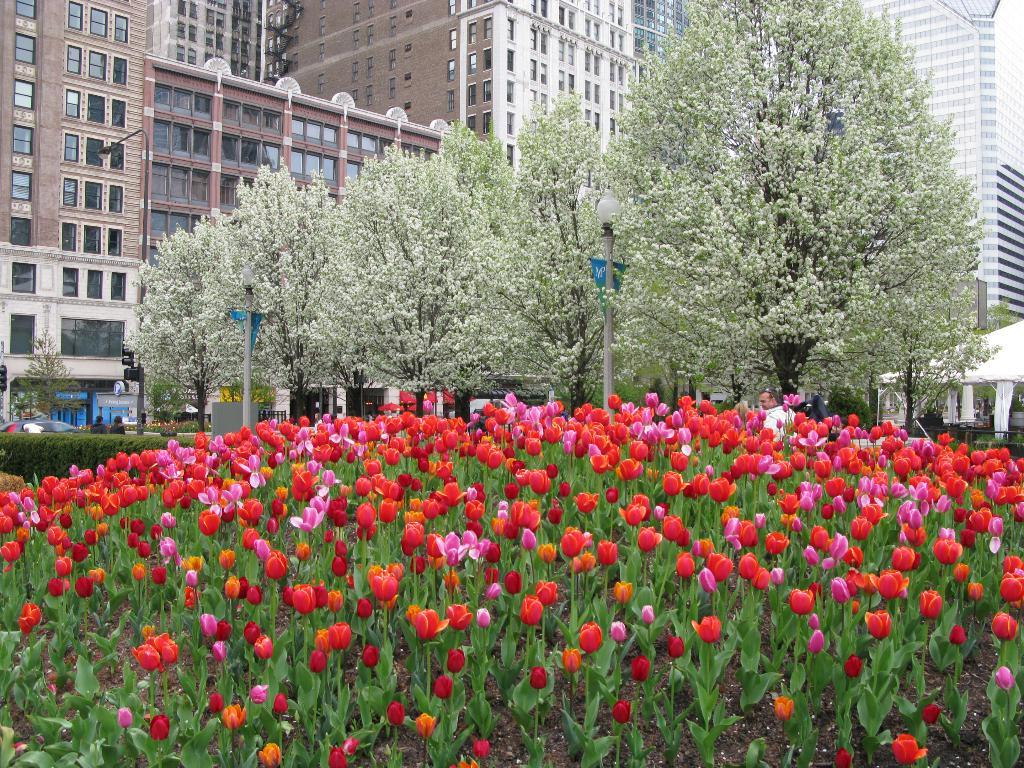What type of natural elements can be seen in the image? There are flowers, leaves, trees, and plants visible in the image. What type of artificial elements can be seen in the image? There are street lights, buildings with glass windows, and a vehicle visible in the image. Are there any living beings present in the image? Yes, there are people present in the image. What is visible at the top of the image? The sky is visible at the top of the image. What type of pocket can be seen in the image? There is no pocket present in the image. What type of voyage is depicted in the image? There is no voyage depicted in the image. 